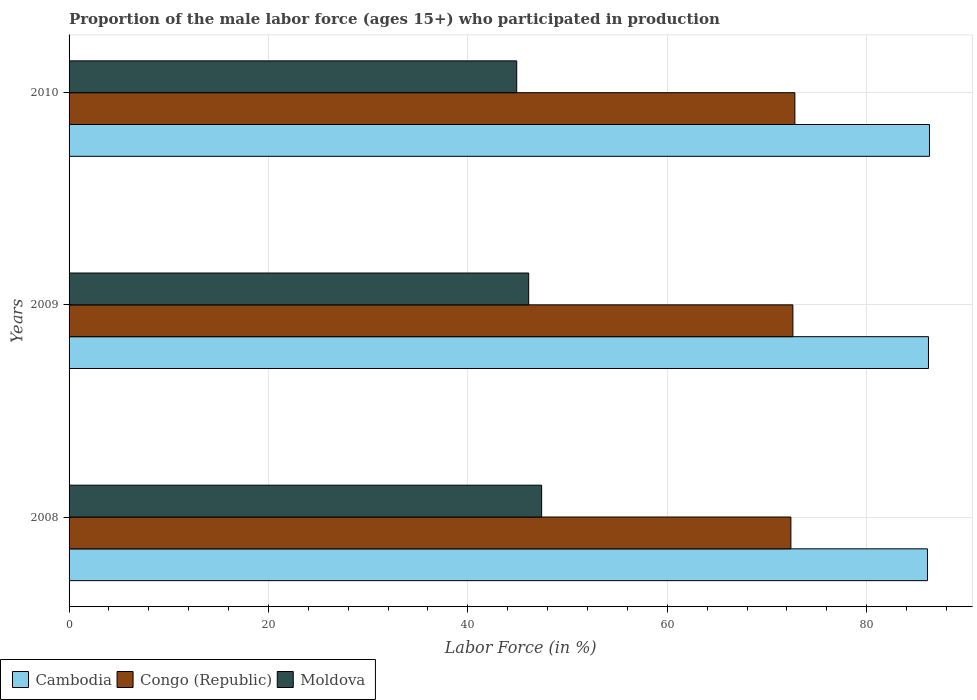How many groups of bars are there?
Your answer should be very brief. 3. How many bars are there on the 3rd tick from the top?
Offer a terse response. 3. What is the label of the 3rd group of bars from the top?
Provide a succinct answer. 2008. In how many cases, is the number of bars for a given year not equal to the number of legend labels?
Offer a very short reply. 0. What is the proportion of the male labor force who participated in production in Cambodia in 2010?
Offer a very short reply. 86.3. Across all years, what is the maximum proportion of the male labor force who participated in production in Moldova?
Make the answer very short. 47.4. Across all years, what is the minimum proportion of the male labor force who participated in production in Moldova?
Your answer should be very brief. 44.9. In which year was the proportion of the male labor force who participated in production in Moldova minimum?
Make the answer very short. 2010. What is the total proportion of the male labor force who participated in production in Cambodia in the graph?
Offer a terse response. 258.6. What is the difference between the proportion of the male labor force who participated in production in Congo (Republic) in 2008 and that in 2009?
Ensure brevity in your answer.  -0.2. What is the difference between the proportion of the male labor force who participated in production in Moldova in 2010 and the proportion of the male labor force who participated in production in Cambodia in 2008?
Offer a very short reply. -41.2. What is the average proportion of the male labor force who participated in production in Cambodia per year?
Your answer should be compact. 86.2. In the year 2009, what is the difference between the proportion of the male labor force who participated in production in Cambodia and proportion of the male labor force who participated in production in Moldova?
Offer a very short reply. 40.1. In how many years, is the proportion of the male labor force who participated in production in Congo (Republic) greater than 48 %?
Provide a short and direct response. 3. What is the ratio of the proportion of the male labor force who participated in production in Moldova in 2009 to that in 2010?
Your response must be concise. 1.03. Is the proportion of the male labor force who participated in production in Cambodia in 2008 less than that in 2009?
Ensure brevity in your answer.  Yes. What is the difference between the highest and the second highest proportion of the male labor force who participated in production in Moldova?
Your response must be concise. 1.3. What is the difference between the highest and the lowest proportion of the male labor force who participated in production in Cambodia?
Ensure brevity in your answer.  0.2. In how many years, is the proportion of the male labor force who participated in production in Congo (Republic) greater than the average proportion of the male labor force who participated in production in Congo (Republic) taken over all years?
Give a very brief answer. 1. Is the sum of the proportion of the male labor force who participated in production in Cambodia in 2008 and 2009 greater than the maximum proportion of the male labor force who participated in production in Congo (Republic) across all years?
Keep it short and to the point. Yes. What does the 3rd bar from the top in 2008 represents?
Provide a short and direct response. Cambodia. What does the 3rd bar from the bottom in 2008 represents?
Keep it short and to the point. Moldova. Is it the case that in every year, the sum of the proportion of the male labor force who participated in production in Moldova and proportion of the male labor force who participated in production in Congo (Republic) is greater than the proportion of the male labor force who participated in production in Cambodia?
Offer a terse response. Yes. Are all the bars in the graph horizontal?
Provide a succinct answer. Yes. How many years are there in the graph?
Keep it short and to the point. 3. Does the graph contain any zero values?
Your answer should be compact. No. Does the graph contain grids?
Provide a succinct answer. Yes. How many legend labels are there?
Provide a succinct answer. 3. How are the legend labels stacked?
Provide a succinct answer. Horizontal. What is the title of the graph?
Your answer should be very brief. Proportion of the male labor force (ages 15+) who participated in production. Does "Nepal" appear as one of the legend labels in the graph?
Give a very brief answer. No. What is the label or title of the X-axis?
Keep it short and to the point. Labor Force (in %). What is the Labor Force (in %) in Cambodia in 2008?
Keep it short and to the point. 86.1. What is the Labor Force (in %) in Congo (Republic) in 2008?
Your answer should be compact. 72.4. What is the Labor Force (in %) of Moldova in 2008?
Keep it short and to the point. 47.4. What is the Labor Force (in %) of Cambodia in 2009?
Ensure brevity in your answer.  86.2. What is the Labor Force (in %) of Congo (Republic) in 2009?
Provide a short and direct response. 72.6. What is the Labor Force (in %) in Moldova in 2009?
Offer a very short reply. 46.1. What is the Labor Force (in %) in Cambodia in 2010?
Provide a succinct answer. 86.3. What is the Labor Force (in %) of Congo (Republic) in 2010?
Give a very brief answer. 72.8. What is the Labor Force (in %) of Moldova in 2010?
Your response must be concise. 44.9. Across all years, what is the maximum Labor Force (in %) of Cambodia?
Offer a terse response. 86.3. Across all years, what is the maximum Labor Force (in %) in Congo (Republic)?
Make the answer very short. 72.8. Across all years, what is the maximum Labor Force (in %) of Moldova?
Offer a very short reply. 47.4. Across all years, what is the minimum Labor Force (in %) in Cambodia?
Your response must be concise. 86.1. Across all years, what is the minimum Labor Force (in %) of Congo (Republic)?
Your response must be concise. 72.4. Across all years, what is the minimum Labor Force (in %) in Moldova?
Give a very brief answer. 44.9. What is the total Labor Force (in %) in Cambodia in the graph?
Keep it short and to the point. 258.6. What is the total Labor Force (in %) in Congo (Republic) in the graph?
Provide a succinct answer. 217.8. What is the total Labor Force (in %) in Moldova in the graph?
Your answer should be compact. 138.4. What is the difference between the Labor Force (in %) in Cambodia in 2008 and that in 2009?
Provide a succinct answer. -0.1. What is the difference between the Labor Force (in %) of Congo (Republic) in 2008 and that in 2009?
Provide a succinct answer. -0.2. What is the difference between the Labor Force (in %) in Cambodia in 2008 and that in 2010?
Provide a succinct answer. -0.2. What is the difference between the Labor Force (in %) in Congo (Republic) in 2008 and that in 2010?
Offer a terse response. -0.4. What is the difference between the Labor Force (in %) of Moldova in 2008 and that in 2010?
Provide a short and direct response. 2.5. What is the difference between the Labor Force (in %) in Cambodia in 2008 and the Labor Force (in %) in Congo (Republic) in 2009?
Make the answer very short. 13.5. What is the difference between the Labor Force (in %) in Cambodia in 2008 and the Labor Force (in %) in Moldova in 2009?
Your answer should be compact. 40. What is the difference between the Labor Force (in %) of Congo (Republic) in 2008 and the Labor Force (in %) of Moldova in 2009?
Make the answer very short. 26.3. What is the difference between the Labor Force (in %) in Cambodia in 2008 and the Labor Force (in %) in Congo (Republic) in 2010?
Your answer should be compact. 13.3. What is the difference between the Labor Force (in %) of Cambodia in 2008 and the Labor Force (in %) of Moldova in 2010?
Your response must be concise. 41.2. What is the difference between the Labor Force (in %) in Congo (Republic) in 2008 and the Labor Force (in %) in Moldova in 2010?
Your response must be concise. 27.5. What is the difference between the Labor Force (in %) of Cambodia in 2009 and the Labor Force (in %) of Moldova in 2010?
Your answer should be compact. 41.3. What is the difference between the Labor Force (in %) in Congo (Republic) in 2009 and the Labor Force (in %) in Moldova in 2010?
Offer a very short reply. 27.7. What is the average Labor Force (in %) in Cambodia per year?
Ensure brevity in your answer.  86.2. What is the average Labor Force (in %) of Congo (Republic) per year?
Offer a terse response. 72.6. What is the average Labor Force (in %) in Moldova per year?
Make the answer very short. 46.13. In the year 2008, what is the difference between the Labor Force (in %) in Cambodia and Labor Force (in %) in Moldova?
Provide a short and direct response. 38.7. In the year 2008, what is the difference between the Labor Force (in %) of Congo (Republic) and Labor Force (in %) of Moldova?
Ensure brevity in your answer.  25. In the year 2009, what is the difference between the Labor Force (in %) in Cambodia and Labor Force (in %) in Congo (Republic)?
Give a very brief answer. 13.6. In the year 2009, what is the difference between the Labor Force (in %) of Cambodia and Labor Force (in %) of Moldova?
Your answer should be very brief. 40.1. In the year 2009, what is the difference between the Labor Force (in %) in Congo (Republic) and Labor Force (in %) in Moldova?
Ensure brevity in your answer.  26.5. In the year 2010, what is the difference between the Labor Force (in %) of Cambodia and Labor Force (in %) of Moldova?
Give a very brief answer. 41.4. In the year 2010, what is the difference between the Labor Force (in %) of Congo (Republic) and Labor Force (in %) of Moldova?
Give a very brief answer. 27.9. What is the ratio of the Labor Force (in %) of Congo (Republic) in 2008 to that in 2009?
Ensure brevity in your answer.  1. What is the ratio of the Labor Force (in %) in Moldova in 2008 to that in 2009?
Ensure brevity in your answer.  1.03. What is the ratio of the Labor Force (in %) in Cambodia in 2008 to that in 2010?
Your answer should be compact. 1. What is the ratio of the Labor Force (in %) of Congo (Republic) in 2008 to that in 2010?
Your response must be concise. 0.99. What is the ratio of the Labor Force (in %) in Moldova in 2008 to that in 2010?
Offer a very short reply. 1.06. What is the ratio of the Labor Force (in %) of Cambodia in 2009 to that in 2010?
Provide a short and direct response. 1. What is the ratio of the Labor Force (in %) of Congo (Republic) in 2009 to that in 2010?
Offer a terse response. 1. What is the ratio of the Labor Force (in %) of Moldova in 2009 to that in 2010?
Provide a short and direct response. 1.03. What is the difference between the highest and the second highest Labor Force (in %) in Moldova?
Give a very brief answer. 1.3. What is the difference between the highest and the lowest Labor Force (in %) of Cambodia?
Ensure brevity in your answer.  0.2. 